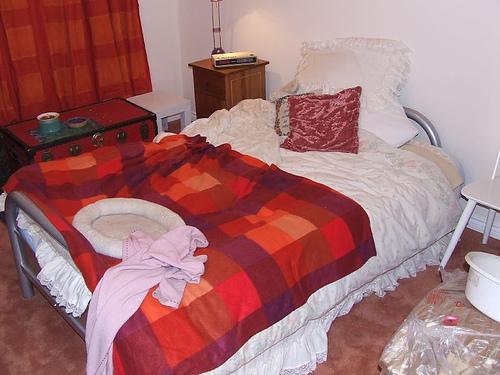Where is a white wood chair?
Keep it brief. By bed. What color is the bed?
Short answer required. White. Does this bedroom look tidy?
Concise answer only. No. 